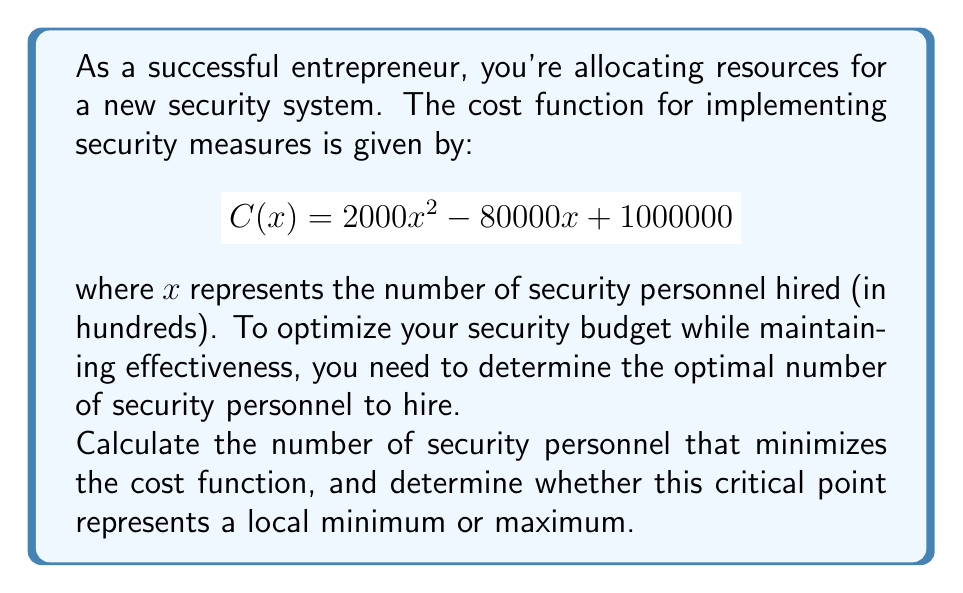Can you solve this math problem? To solve this optimization problem, we'll use the following steps:

1) Find the first derivative of the cost function:
   $$C'(x) = 4000x - 80000$$

2) Set the first derivative to zero and solve for x:
   $$4000x - 80000 = 0$$
   $$4000x = 80000$$
   $$x = 20$$

3) This critical point (x = 20) could be either a minimum or maximum. To determine which, we need to find the second derivative:
   $$C''(x) = 4000$$

4) Evaluate the second derivative at the critical point:
   $$C''(20) = 4000$$

5) Since the second derivative is positive, this confirms that x = 20 is a local minimum.

6) Interpret the result: x = 20 represents 20 hundred, or 2000 security personnel.
Answer: 2000 personnel; local minimum 